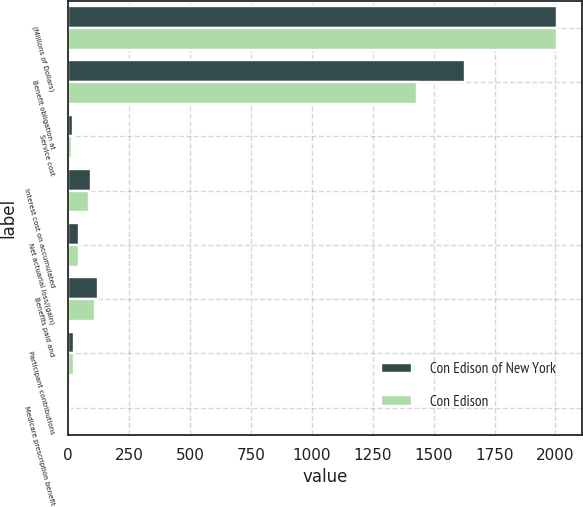Convert chart to OTSL. <chart><loc_0><loc_0><loc_500><loc_500><stacked_bar_chart><ecel><fcel>(Millions of Dollars)<fcel>Benefit obligation at<fcel>Service cost<fcel>Interest cost on accumulated<fcel>Net actuarial loss/(gain)<fcel>Benefits paid and<fcel>Participant contributions<fcel>Medicare prescription benefit<nl><fcel>Con Edison of New York<fcel>2008<fcel>1630<fcel>20<fcel>95<fcel>46<fcel>121<fcel>25<fcel>7<nl><fcel>Con Edison<fcel>2008<fcel>1433<fcel>16<fcel>84<fcel>44<fcel>111<fcel>24<fcel>5<nl></chart> 